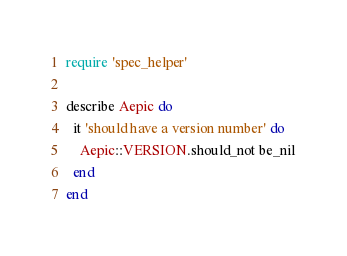<code> <loc_0><loc_0><loc_500><loc_500><_Ruby_>require 'spec_helper'

describe Aepic do
  it 'should have a version number' do
    Aepic::VERSION.should_not be_nil
  end
end
</code> 